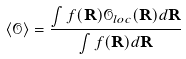<formula> <loc_0><loc_0><loc_500><loc_500>\langle { \mathcal { O } } \rangle = \frac { \int f ( { \mathbf R } ) { \mathcal { O } } _ { l o c } ( { \mathbf R } ) d { \mathbf R } } { \int f ( { \mathbf R } ) d { \mathbf R } }</formula> 